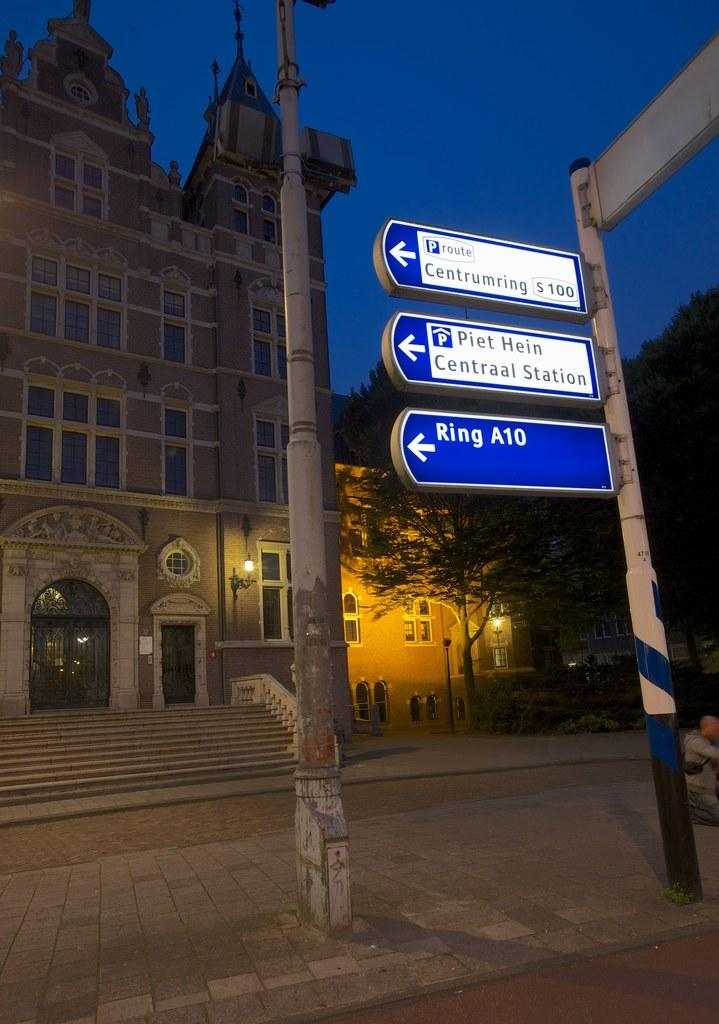What type of structures can be seen in the image? There are houses and buildings in the image. Are there any other objects or features in the image besides the structures? Yes, there are poles with boards in the image. What type of oatmeal is being served in the image? There is no oatmeal present in the image. How does the steam rise from the land in the image? There is no land or steam present in the image. 